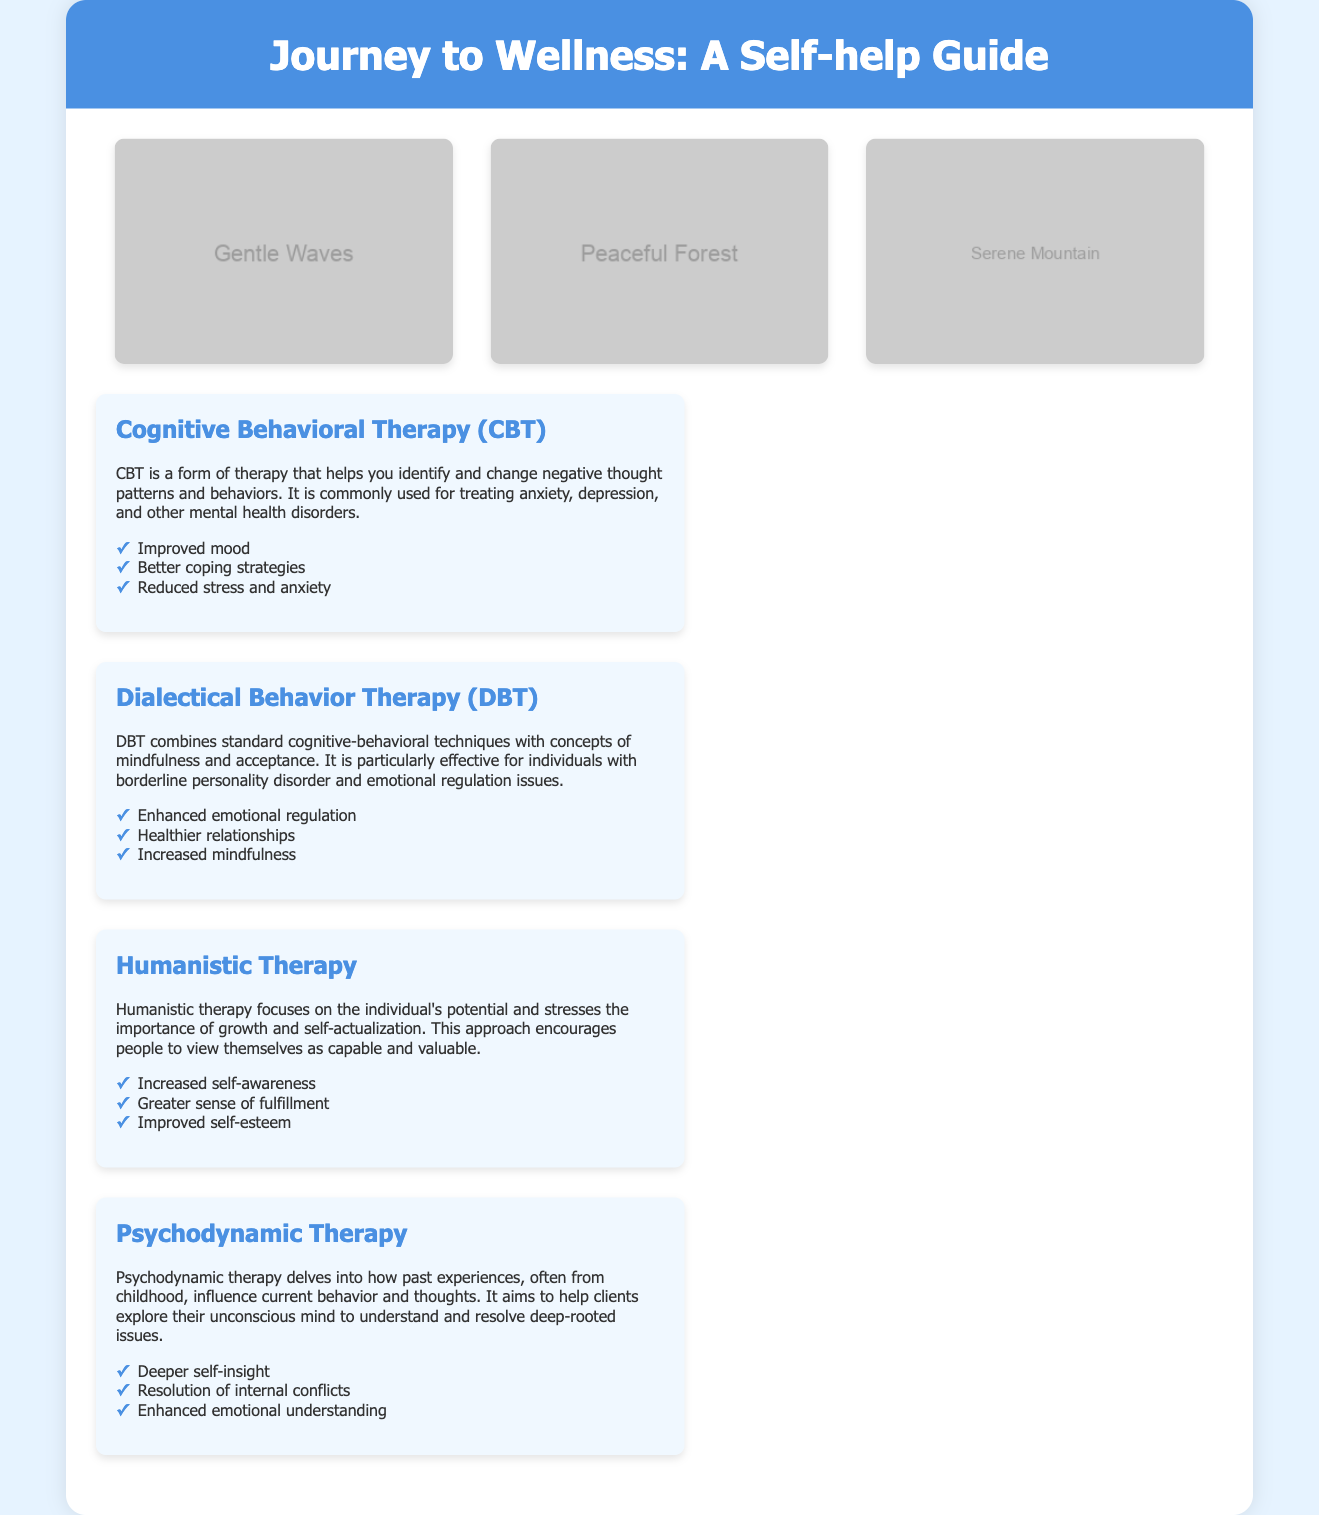What is the title of the book? The title of the book is displayed prominently in the header of the document.
Answer: Journey to Wellness: A Self-help Guide What color scheme is used in the packaging? The color scheme is described in the document's introductory sections, indicating the overall design choice.
Answer: Serene blue How many therapeutic techniques are summarized in the book? The content section lists four different therapeutic techniques discussed in the book.
Answer: Four Which therapy focuses on emotional regulation? This therapy is specifically mentioned in the description section focused on emotional challenges.
Answer: Dialectical Behavior Therapy (DBT) What type of images are included in the illustration section? The illustrations depict nature scenes, as mentioned in the header section before the images.
Answer: Calm nature scenes What is one benefit of Cognitive Behavioral Therapy? This is found in the benefits section of the CBT description, which lists notable advantages of the therapy.
Answer: Improved mood Which therapy is associated with self-actualization? The technique mentioned focuses on individual growth and potential.
Answer: Humanistic Therapy What does Psychodynamic Therapy aim to explore? The explanation in the document highlights what this therapeutic approach seeks to understand.
Answer: The unconscious mind 